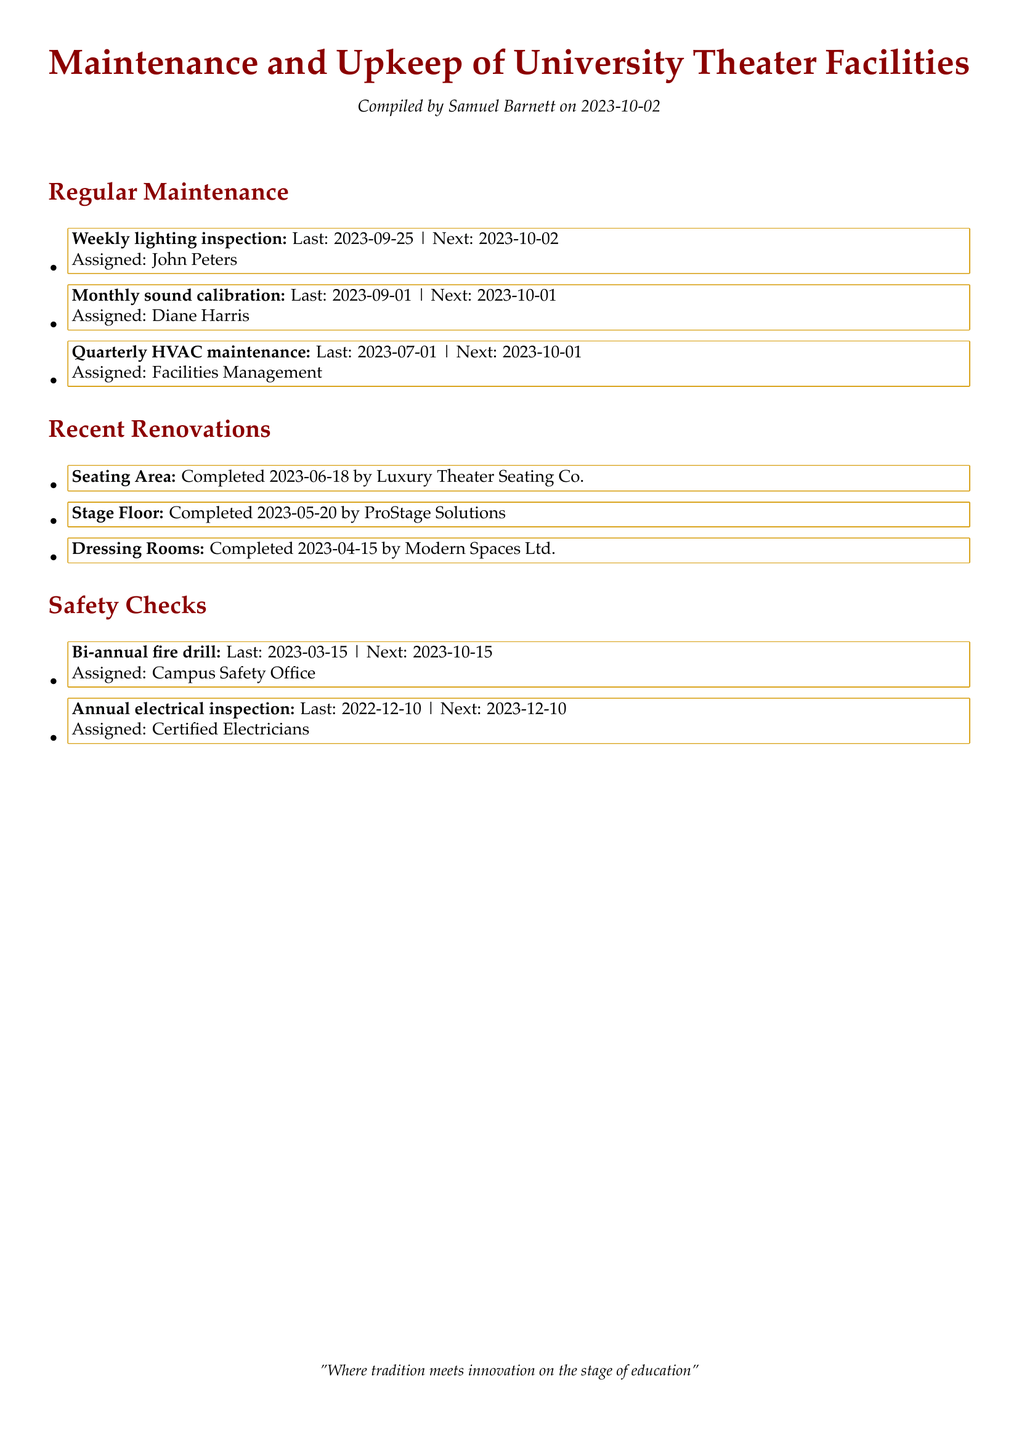What was the last date for lighting inspection? The last date for the weekly lighting inspection is listed in the document as 2023-09-25.
Answer: 2023-09-25 Who was assigned to the monthly sound calibration? The document specifies that Diane Harris is assigned to the monthly sound calibration.
Answer: Diane Harris When was the seating area completed? The completion date for the seating area renovation is noted in the document as 2023-06-18.
Answer: 2023-06-18 Which company completed the stage floor renovation? The document states that ProStage Solutions completed the stage floor renovation.
Answer: ProStage Solutions What is the next scheduled date for the annual electrical inspection? The next scheduled date for the annual electrical inspection is provided in the document as 2023-12-10.
Answer: 2023-12-10 How often is the HVAC maintenance conducted? The maintenance log indicates that HVAC maintenance is conducted quarterly.
Answer: Quarterly When is the next bi-annual fire drill scheduled? According to the document, the next bi-annual fire drill is scheduled for 2023-10-15.
Answer: 2023-10-15 Which entity is responsible for the upcoming HVAC maintenance? The document lists Facilities Management as the responsible entity for the upcoming HVAC maintenance.
Answer: Facilities Management What was the last date for the bi-annual fire drill? The last date for the bi-annual fire drill is stated in the document as 2023-03-15.
Answer: 2023-03-15 